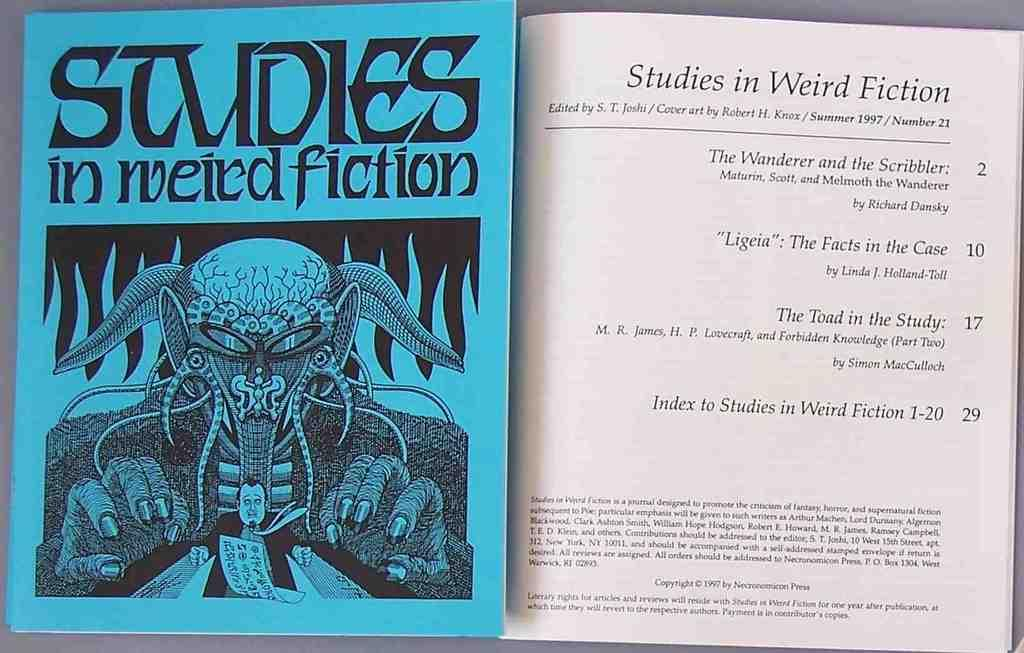<image>
Provide a brief description of the given image. the cover and index page of the book "studies in weird fiction". 